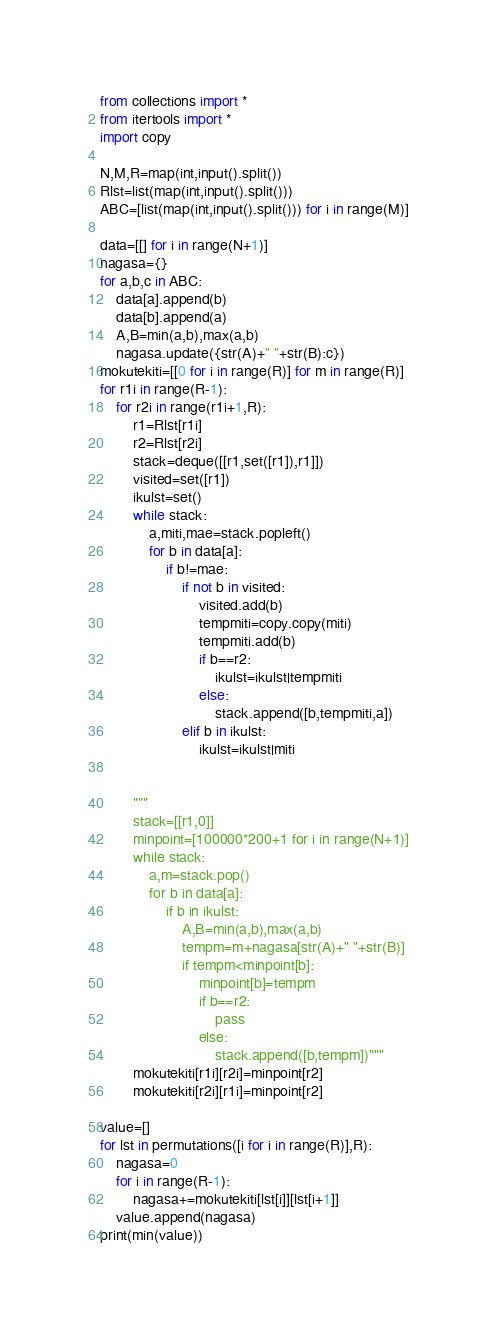Convert code to text. <code><loc_0><loc_0><loc_500><loc_500><_Python_>from collections import *
from itertools import *
import copy

N,M,R=map(int,input().split())
Rlst=list(map(int,input().split()))
ABC=[list(map(int,input().split())) for i in range(M)]

data=[[] for i in range(N+1)]
nagasa={}
for a,b,c in ABC:
    data[a].append(b)
    data[b].append(a)
    A,B=min(a,b),max(a,b)
    nagasa.update({str(A)+" "+str(B):c})
mokutekiti=[[0 for i in range(R)] for m in range(R)]
for r1i in range(R-1):
    for r2i in range(r1i+1,R):
        r1=Rlst[r1i]
        r2=Rlst[r2i]
        stack=deque([[r1,set([r1]),r1]])
        visited=set([r1])
        ikulst=set()
        while stack:
            a,miti,mae=stack.popleft()
            for b in data[a]:
                if b!=mae:
                    if not b in visited:
                        visited.add(b)
                        tempmiti=copy.copy(miti)
                        tempmiti.add(b)
                        if b==r2:
                            ikulst=ikulst|tempmiti
                        else:
                            stack.append([b,tempmiti,a])
                    elif b in ikulst:
                        ikulst=ikulst|miti


        """
        stack=[[r1,0]]
        minpoint=[100000*200+1 for i in range(N+1)]
        while stack:
            a,m=stack.pop()
            for b in data[a]:
                if b in ikulst:
                    A,B=min(a,b),max(a,b)
                    tempm=m+nagasa[str(A)+" "+str(B)]
                    if tempm<minpoint[b]:
                        minpoint[b]=tempm
                        if b==r2:
                            pass
                        else:
                            stack.append([b,tempm])"""
        mokutekiti[r1i][r2i]=minpoint[r2]
        mokutekiti[r2i][r1i]=minpoint[r2]

value=[]
for lst in permutations([i for i in range(R)],R):
    nagasa=0
    for i in range(R-1):
        nagasa+=mokutekiti[lst[i]][lst[i+1]]
    value.append(nagasa)
print(min(value))
</code> 